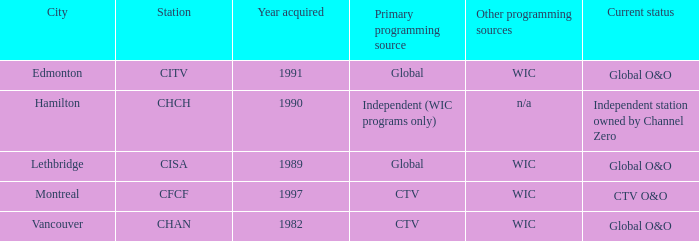As the chan, how many were obtained? 1.0. 